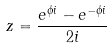Convert formula to latex. <formula><loc_0><loc_0><loc_500><loc_500>z = { \frac { e ^ { \phi i } - e ^ { - \phi i } } { 2 i } }</formula> 